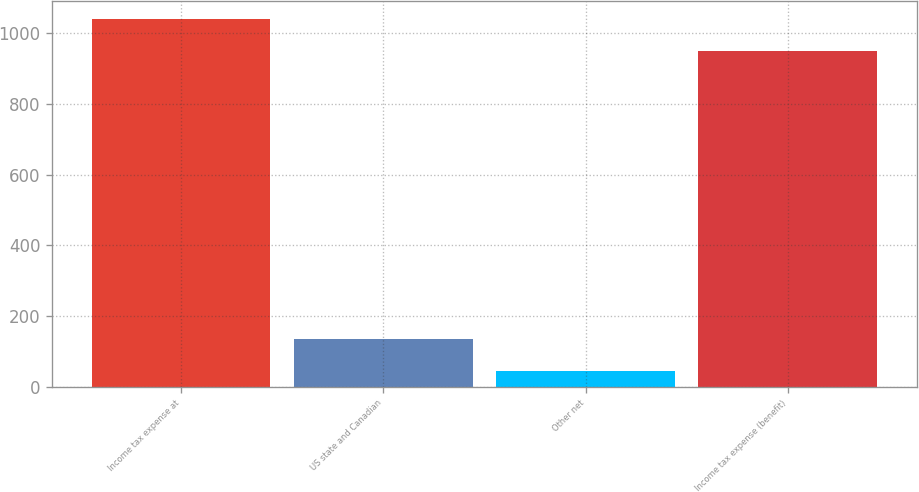<chart> <loc_0><loc_0><loc_500><loc_500><bar_chart><fcel>Income tax expense at<fcel>US state and Canadian<fcel>Other net<fcel>Income tax expense (benefit)<nl><fcel>1040.2<fcel>136.2<fcel>45<fcel>949<nl></chart> 